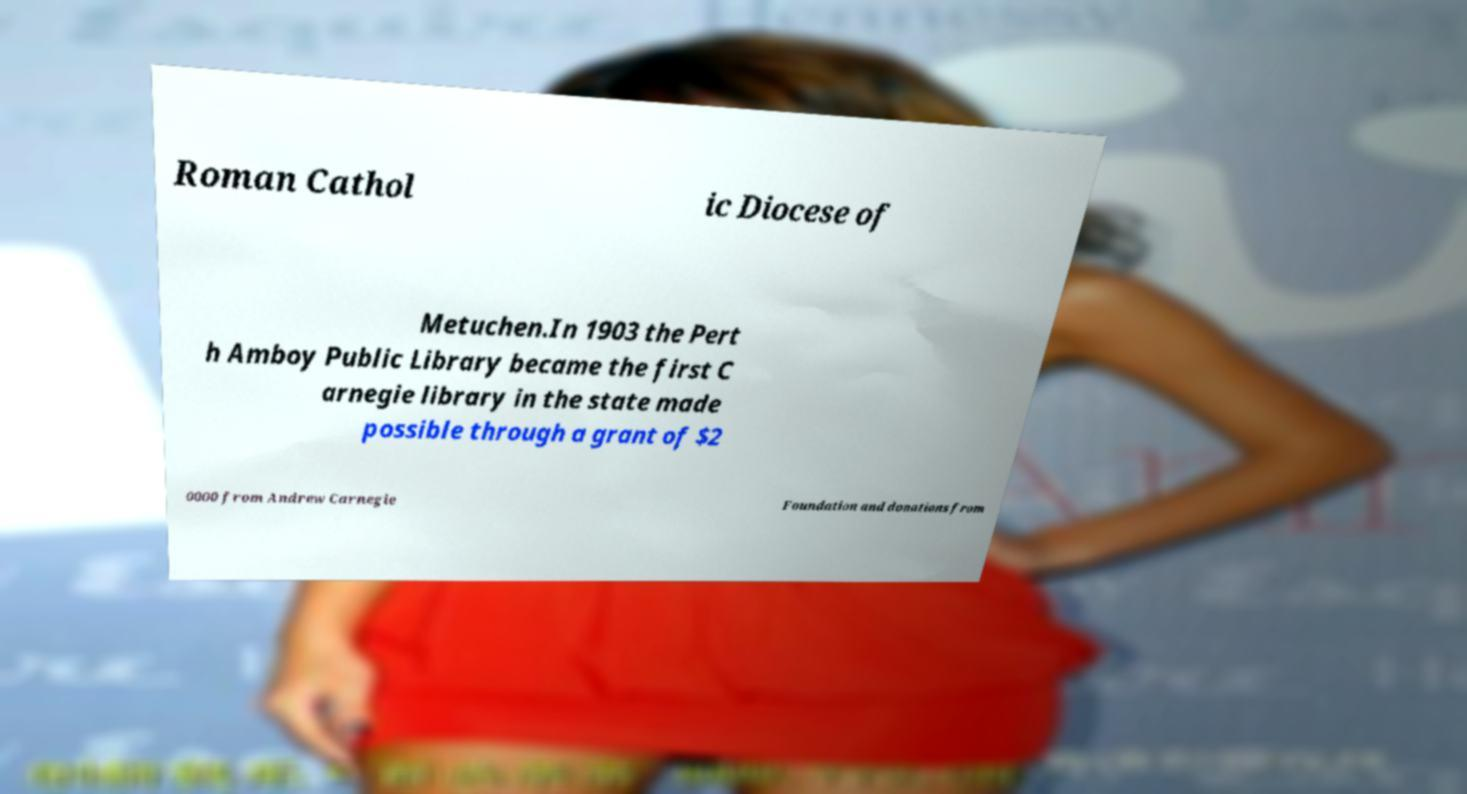Could you assist in decoding the text presented in this image and type it out clearly? Roman Cathol ic Diocese of Metuchen.In 1903 the Pert h Amboy Public Library became the first C arnegie library in the state made possible through a grant of $2 0000 from Andrew Carnegie Foundation and donations from 